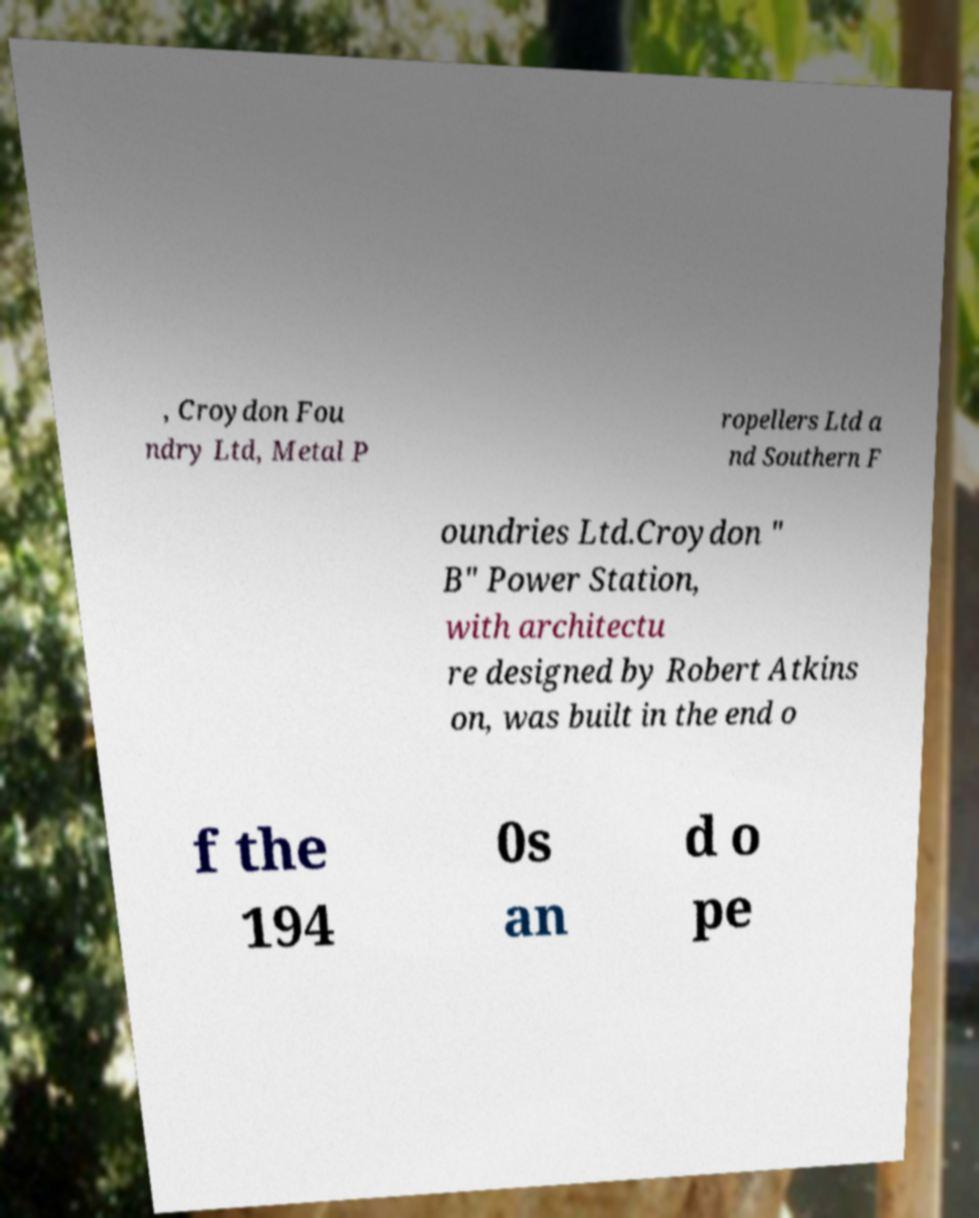Can you read and provide the text displayed in the image?This photo seems to have some interesting text. Can you extract and type it out for me? , Croydon Fou ndry Ltd, Metal P ropellers Ltd a nd Southern F oundries Ltd.Croydon " B" Power Station, with architectu re designed by Robert Atkins on, was built in the end o f the 194 0s an d o pe 